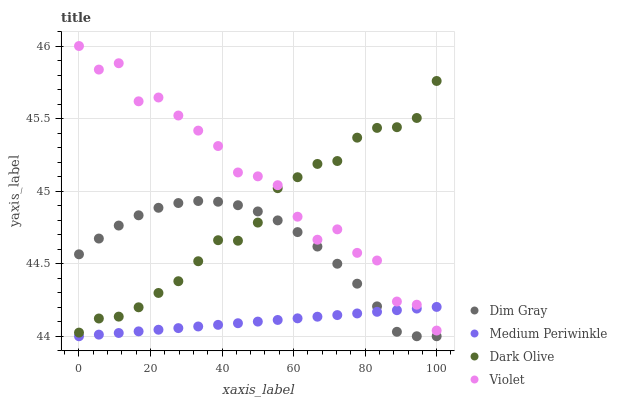Does Medium Periwinkle have the minimum area under the curve?
Answer yes or no. Yes. Does Violet have the maximum area under the curve?
Answer yes or no. Yes. Does Dim Gray have the minimum area under the curve?
Answer yes or no. No. Does Dim Gray have the maximum area under the curve?
Answer yes or no. No. Is Medium Periwinkle the smoothest?
Answer yes or no. Yes. Is Violet the roughest?
Answer yes or no. Yes. Is Dim Gray the smoothest?
Answer yes or no. No. Is Dim Gray the roughest?
Answer yes or no. No. Does Dim Gray have the lowest value?
Answer yes or no. Yes. Does Violet have the lowest value?
Answer yes or no. No. Does Violet have the highest value?
Answer yes or no. Yes. Does Dim Gray have the highest value?
Answer yes or no. No. Is Medium Periwinkle less than Dark Olive?
Answer yes or no. Yes. Is Violet greater than Dim Gray?
Answer yes or no. Yes. Does Medium Periwinkle intersect Dim Gray?
Answer yes or no. Yes. Is Medium Periwinkle less than Dim Gray?
Answer yes or no. No. Is Medium Periwinkle greater than Dim Gray?
Answer yes or no. No. Does Medium Periwinkle intersect Dark Olive?
Answer yes or no. No. 